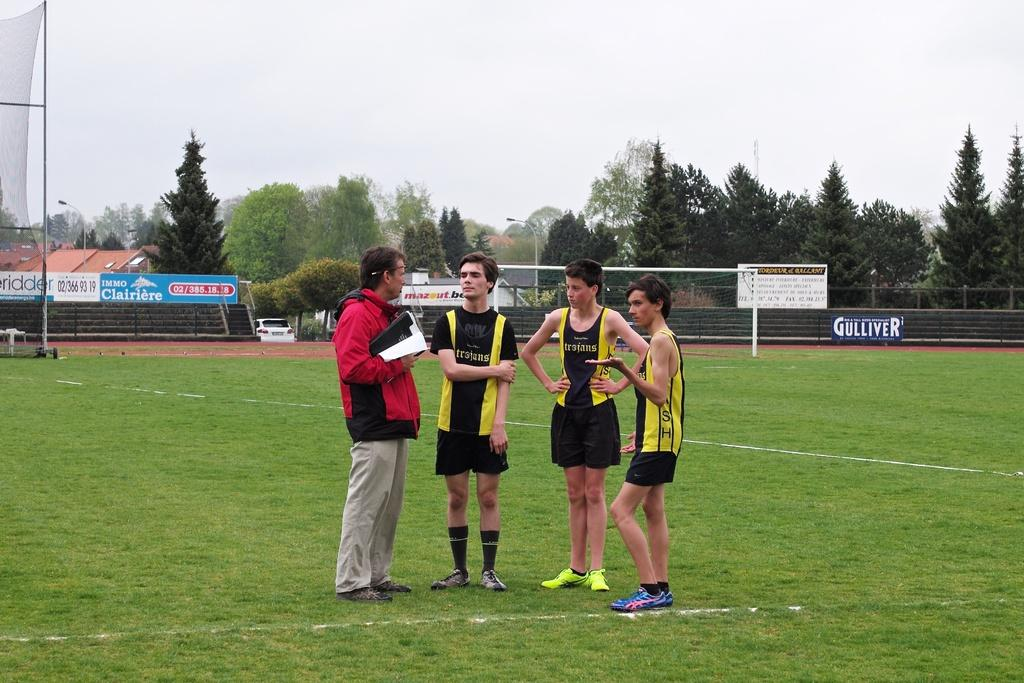<image>
Give a short and clear explanation of the subsequent image. The team that the boys are representing are the Trojans. 